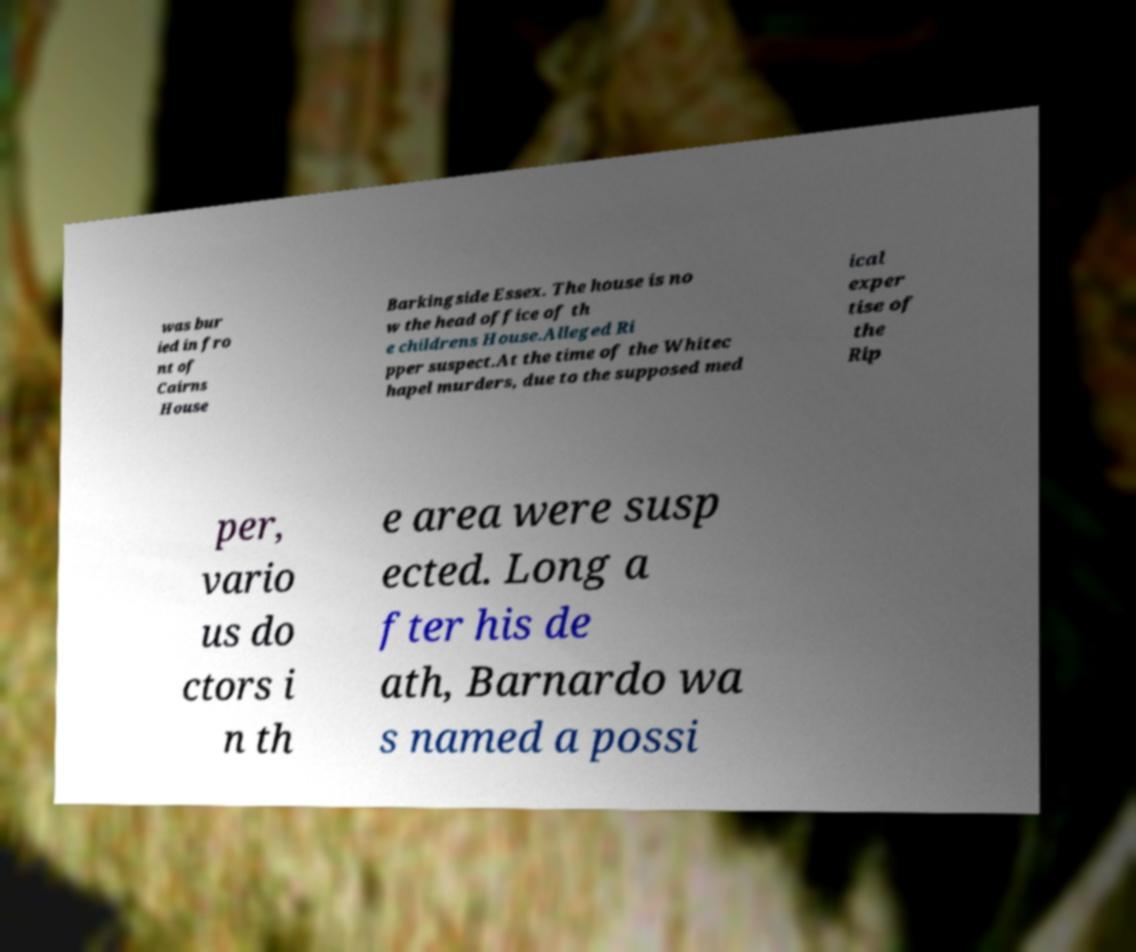What messages or text are displayed in this image? I need them in a readable, typed format. was bur ied in fro nt of Cairns House Barkingside Essex. The house is no w the head office of th e childrens House.Alleged Ri pper suspect.At the time of the Whitec hapel murders, due to the supposed med ical exper tise of the Rip per, vario us do ctors i n th e area were susp ected. Long a fter his de ath, Barnardo wa s named a possi 